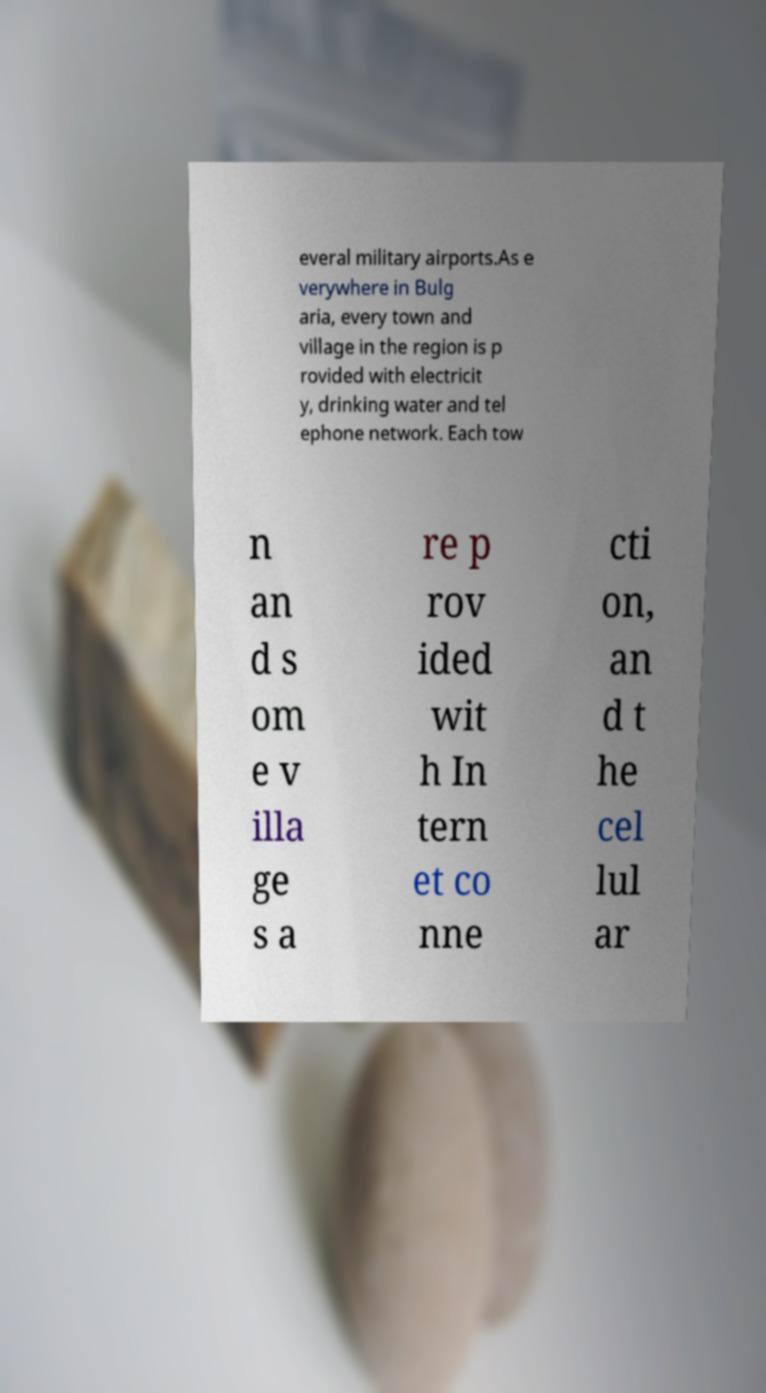I need the written content from this picture converted into text. Can you do that? everal military airports.As e verywhere in Bulg aria, every town and village in the region is p rovided with electricit y, drinking water and tel ephone network. Each tow n an d s om e v illa ge s a re p rov ided wit h In tern et co nne cti on, an d t he cel lul ar 